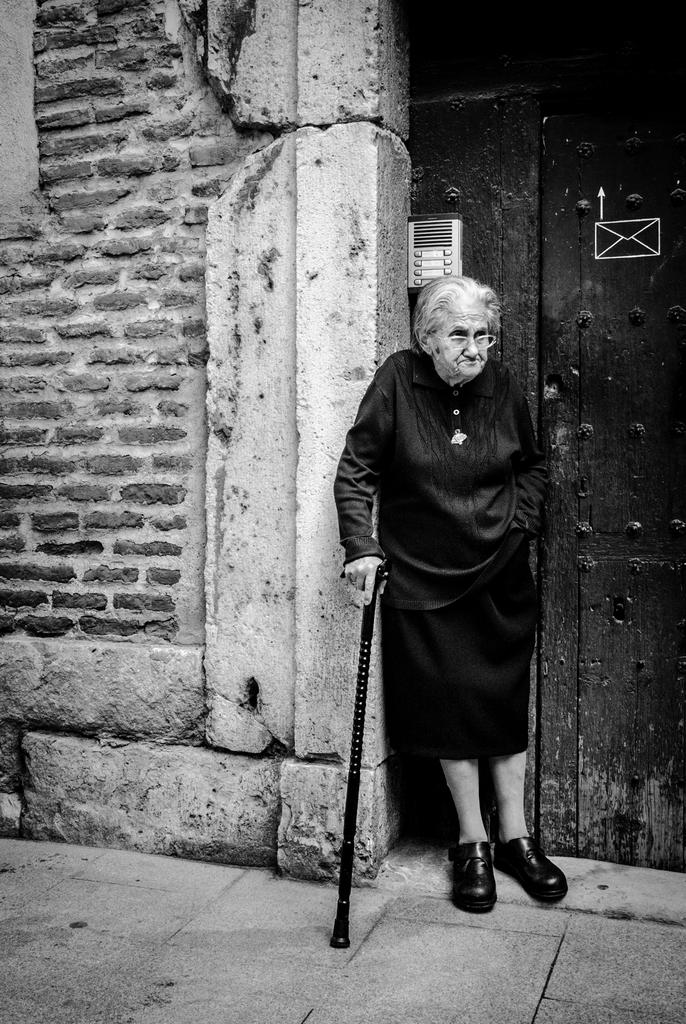What is the primary subject of the image? There is a woman in the image. What is the woman doing in the image? The woman is standing in the image. What object is the woman holding in her hand? The woman is holding a stick in her hand. What architectural feature can be seen in the image? There is a door visible in the image, and behind the door, there is a brick wall. How does the woman compare to the other writers in the library? There is no mention of other writers or a library in the provided facts. 